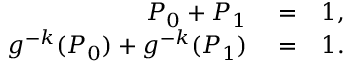Convert formula to latex. <formula><loc_0><loc_0><loc_500><loc_500>\begin{array} { r l r } { P _ { 0 } + P _ { 1 } } & = } & { 1 , } \\ { g ^ { - k } ( P _ { 0 } ) + g ^ { - k } ( P _ { 1 } ) } & = } & { 1 . } \end{array}</formula> 